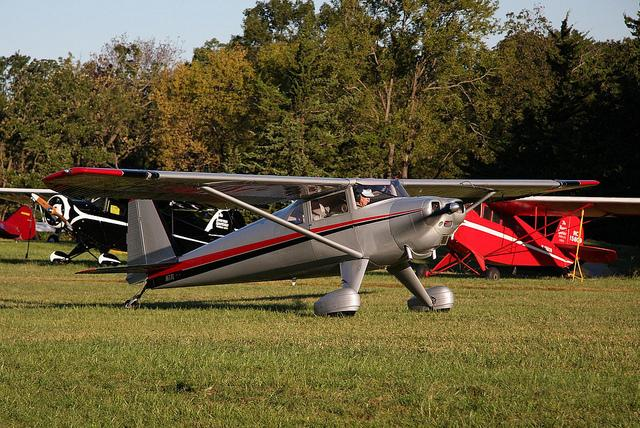What powers this plane? Please explain your reasoning. gasoline. The plane sitting on the gas is powered by gasoline when running. 